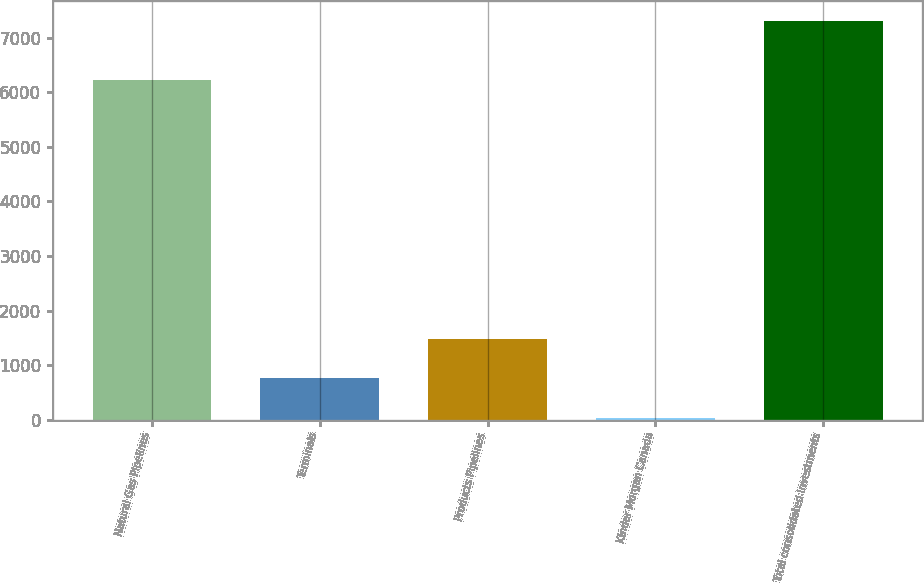Convert chart. <chart><loc_0><loc_0><loc_500><loc_500><bar_chart><fcel>Natural Gas Pipelines<fcel>Terminals<fcel>Products Pipelines<fcel>Kinder Morgan Canada<fcel>Total consolidated investments<nl><fcel>6218<fcel>760.4<fcel>1486.8<fcel>34<fcel>7298<nl></chart> 